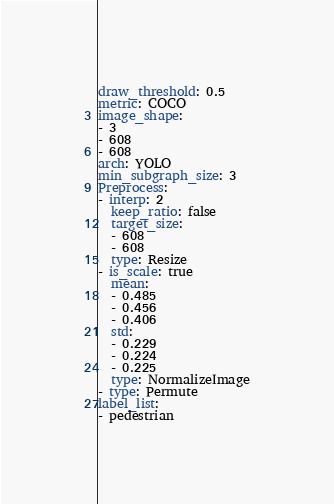<code> <loc_0><loc_0><loc_500><loc_500><_YAML_>draw_threshold: 0.5
metric: COCO
image_shape:
- 3
- 608
- 608
arch: YOLO
min_subgraph_size: 3
Preprocess:
- interp: 2
  keep_ratio: false
  target_size:
  - 608
  - 608
  type: Resize
- is_scale: true
  mean:
  - 0.485
  - 0.456
  - 0.406
  std:
  - 0.229
  - 0.224
  - 0.225
  type: NormalizeImage
- type: Permute
label_list:
- pedestrian
</code> 